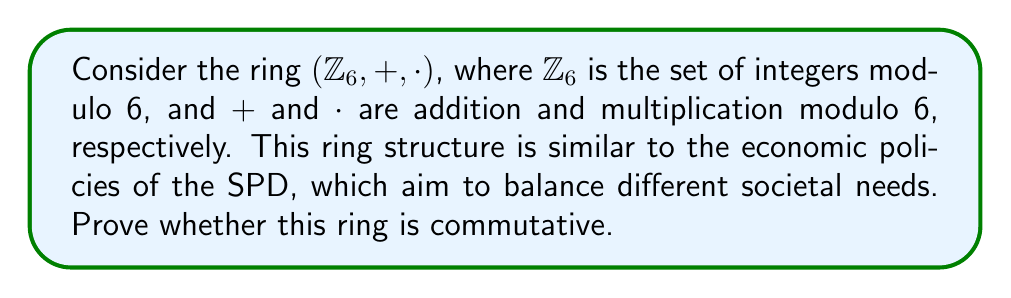What is the answer to this math problem? To prove whether the ring $(\mathbb{Z}_6, +, \cdot)$ is commutative, we need to show that both addition and multiplication are commutative operations.

1. Commutativity of addition:
   For any $a, b \in \mathbb{Z}_6$, we need to show that $a + b \equiv b + a \pmod{6}$. 
   This is true because addition of integers is commutative, and the modulo operation preserves this property.

2. Commutativity of multiplication:
   For any $a, b \in \mathbb{Z}_6$, we need to show that $a \cdot b \equiv b \cdot a \pmod{6}$.
   This is true because multiplication of integers is commutative, and the modulo operation preserves this property.

3. Verification:
   We can verify this for all pairs of elements in $\mathbb{Z}_6 = \{0, 1, 2, 3, 4, 5\}$. 
   For example:
   $2 \cdot 3 \equiv 0 \pmod{6}$ and $3 \cdot 2 \equiv 0 \pmod{6}$
   $4 \cdot 5 \equiv 2 \pmod{6}$ and $5 \cdot 4 \equiv 2 \pmod{6}$

Since both addition and multiplication are commutative operations in $\mathbb{Z}_6$, we can conclude that the ring $(\mathbb{Z}_6, +, \cdot)$ is commutative.
Answer: The ring $(\mathbb{Z}_6, +, \cdot)$ is commutative. 